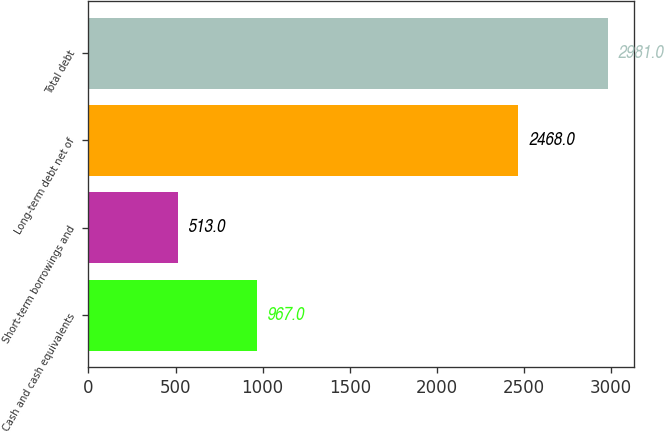<chart> <loc_0><loc_0><loc_500><loc_500><bar_chart><fcel>Cash and cash equivalents<fcel>Short-term borrowings and<fcel>Long-term debt net of<fcel>Total debt<nl><fcel>967<fcel>513<fcel>2468<fcel>2981<nl></chart> 